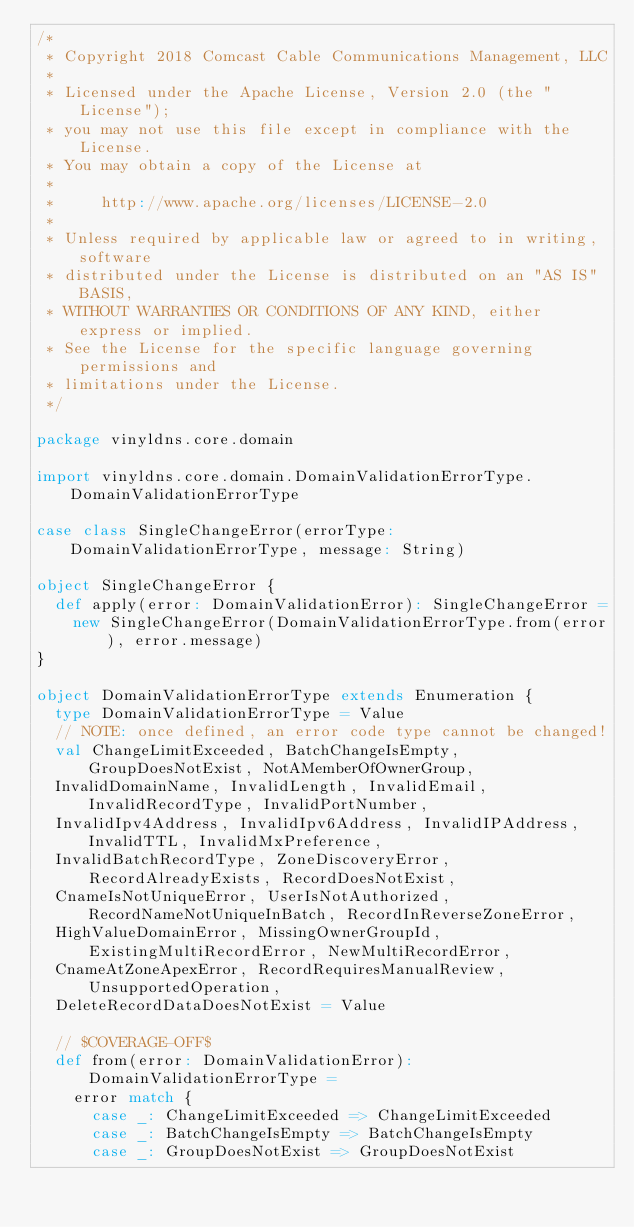Convert code to text. <code><loc_0><loc_0><loc_500><loc_500><_Scala_>/*
 * Copyright 2018 Comcast Cable Communications Management, LLC
 *
 * Licensed under the Apache License, Version 2.0 (the "License");
 * you may not use this file except in compliance with the License.
 * You may obtain a copy of the License at
 *
 *     http://www.apache.org/licenses/LICENSE-2.0
 *
 * Unless required by applicable law or agreed to in writing, software
 * distributed under the License is distributed on an "AS IS" BASIS,
 * WITHOUT WARRANTIES OR CONDITIONS OF ANY KIND, either express or implied.
 * See the License for the specific language governing permissions and
 * limitations under the License.
 */

package vinyldns.core.domain

import vinyldns.core.domain.DomainValidationErrorType.DomainValidationErrorType

case class SingleChangeError(errorType: DomainValidationErrorType, message: String)

object SingleChangeError {
  def apply(error: DomainValidationError): SingleChangeError =
    new SingleChangeError(DomainValidationErrorType.from(error), error.message)
}

object DomainValidationErrorType extends Enumeration {
  type DomainValidationErrorType = Value
  // NOTE: once defined, an error code type cannot be changed!
  val ChangeLimitExceeded, BatchChangeIsEmpty, GroupDoesNotExist, NotAMemberOfOwnerGroup,
  InvalidDomainName, InvalidLength, InvalidEmail, InvalidRecordType, InvalidPortNumber,
  InvalidIpv4Address, InvalidIpv6Address, InvalidIPAddress, InvalidTTL, InvalidMxPreference,
  InvalidBatchRecordType, ZoneDiscoveryError, RecordAlreadyExists, RecordDoesNotExist,
  CnameIsNotUniqueError, UserIsNotAuthorized, RecordNameNotUniqueInBatch, RecordInReverseZoneError,
  HighValueDomainError, MissingOwnerGroupId, ExistingMultiRecordError, NewMultiRecordError,
  CnameAtZoneApexError, RecordRequiresManualReview, UnsupportedOperation,
  DeleteRecordDataDoesNotExist = Value

  // $COVERAGE-OFF$
  def from(error: DomainValidationError): DomainValidationErrorType =
    error match {
      case _: ChangeLimitExceeded => ChangeLimitExceeded
      case _: BatchChangeIsEmpty => BatchChangeIsEmpty
      case _: GroupDoesNotExist => GroupDoesNotExist</code> 